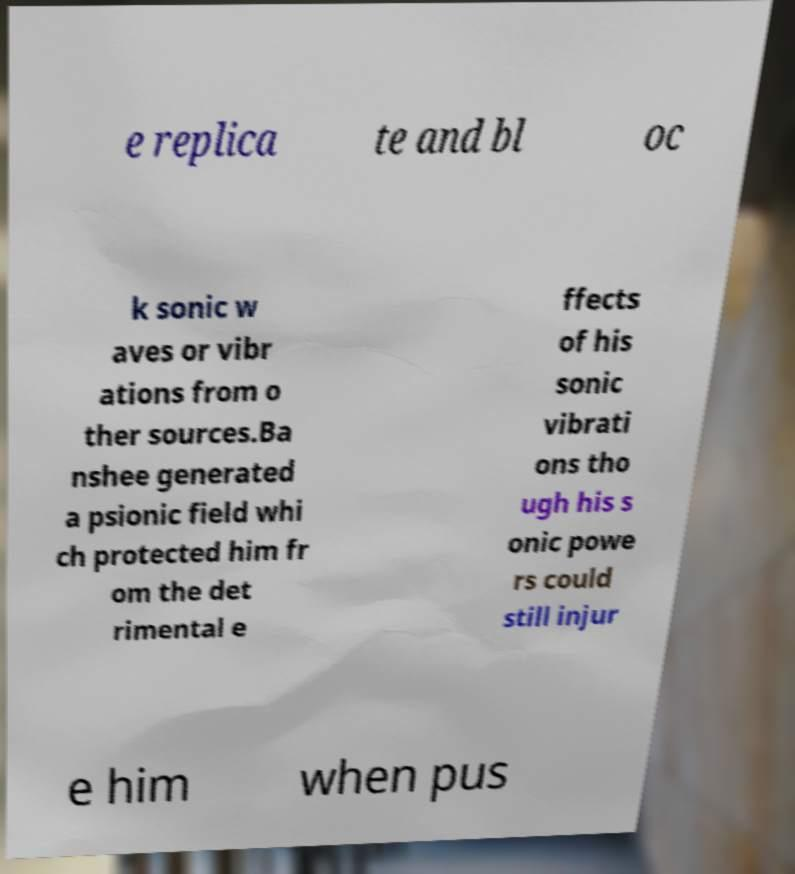What messages or text are displayed in this image? I need them in a readable, typed format. e replica te and bl oc k sonic w aves or vibr ations from o ther sources.Ba nshee generated a psionic field whi ch protected him fr om the det rimental e ffects of his sonic vibrati ons tho ugh his s onic powe rs could still injur e him when pus 